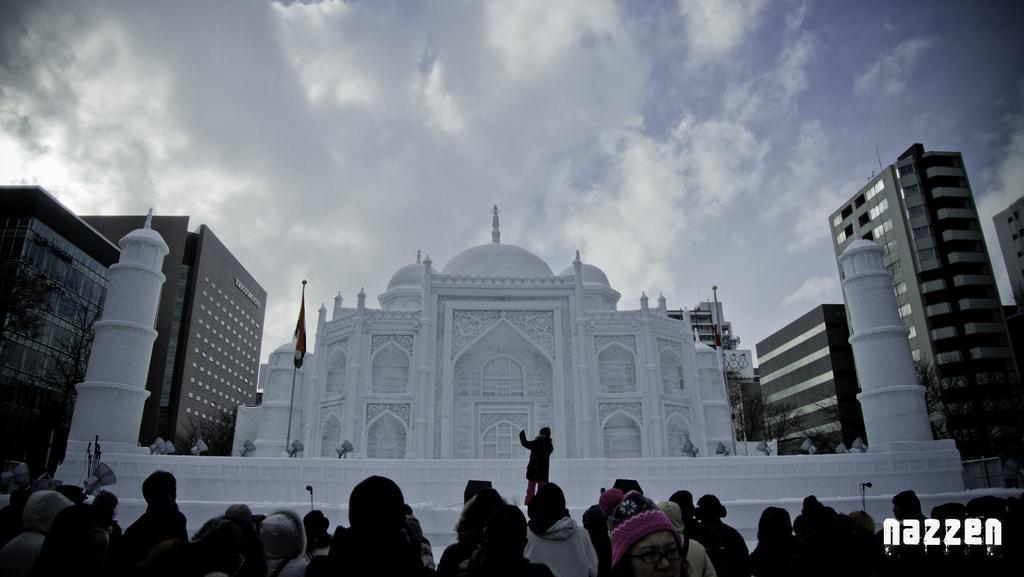Please provide a concise description of this image. At the bottom of the image few people are standing. Behind them there are some buildings. At the top of the image there are some clouds and sky. 